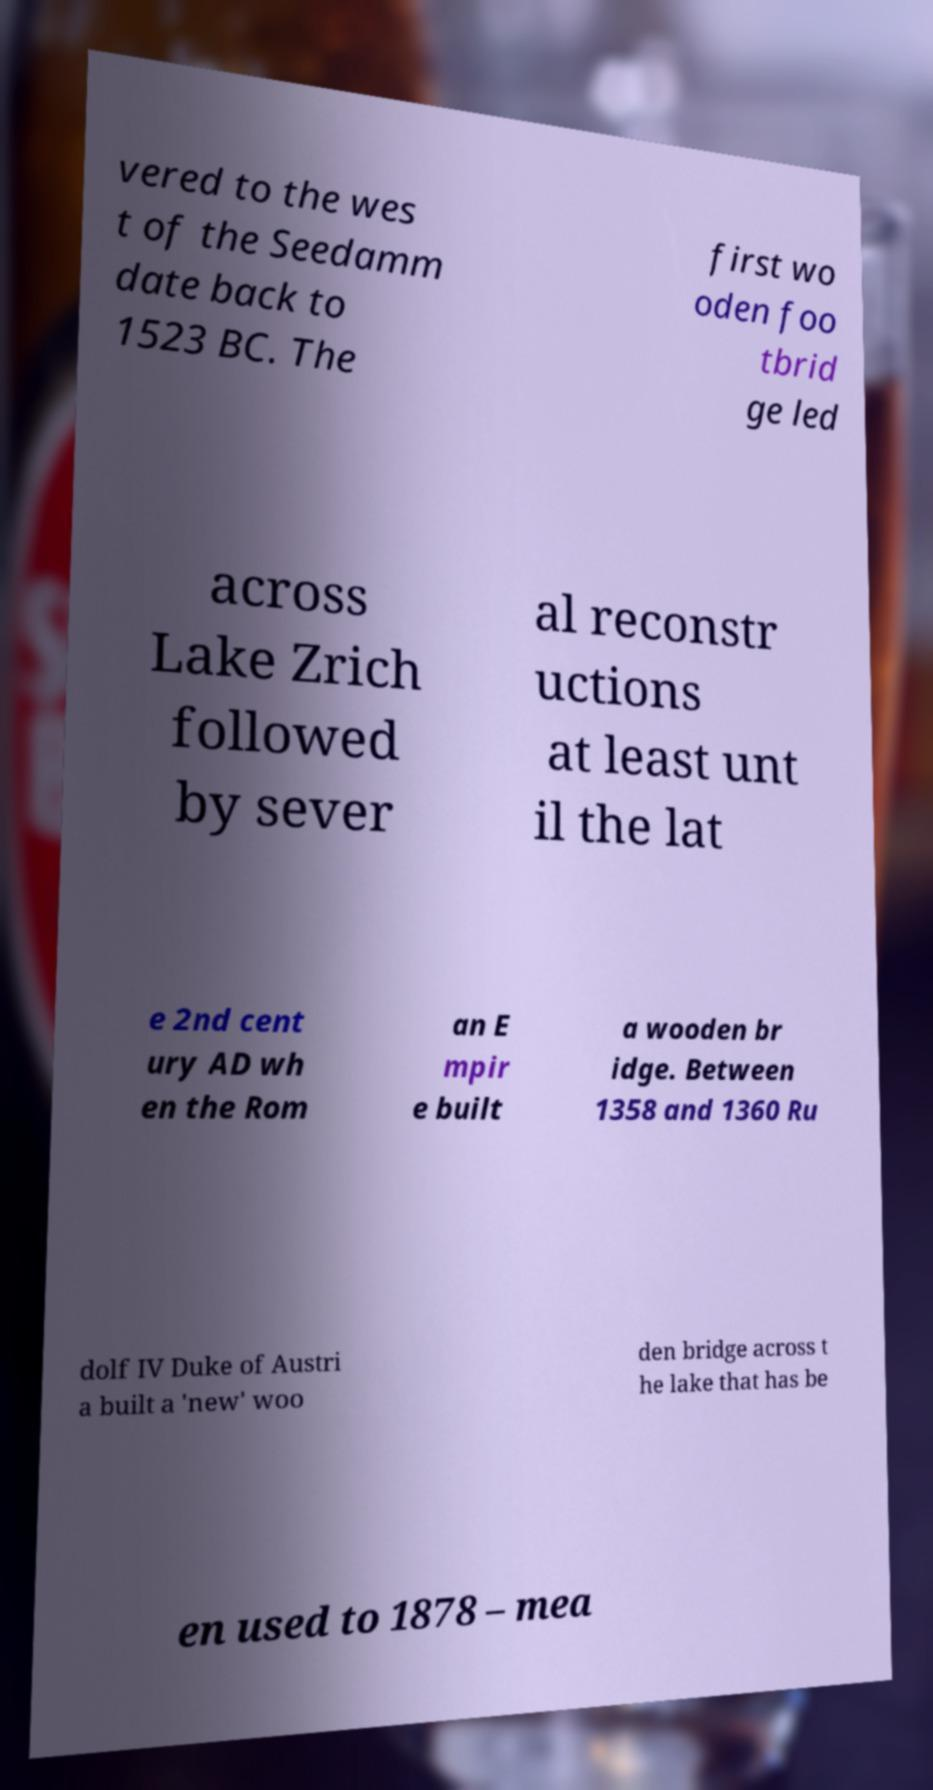I need the written content from this picture converted into text. Can you do that? vered to the wes t of the Seedamm date back to 1523 BC. The first wo oden foo tbrid ge led across Lake Zrich followed by sever al reconstr uctions at least unt il the lat e 2nd cent ury AD wh en the Rom an E mpir e built a wooden br idge. Between 1358 and 1360 Ru dolf IV Duke of Austri a built a 'new' woo den bridge across t he lake that has be en used to 1878 – mea 